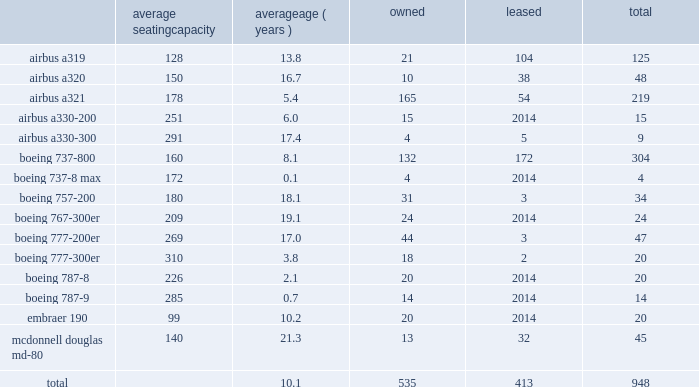Item 2 .
Properties flight equipment and fleet renewal as of december 31 , 2017 , american operated a mainline fleet of 948 aircraft .
In 2017 , we continued our extensive fleet renewal program , which has provided us with the youngest fleet of the major u.s .
Network carriers .
During 2017 , american took delivery of 57 new mainline aircraft and retired 39 mainline aircraft .
We are supported by our wholly-owned and third-party regional carriers that fly under capacity purchase agreements operating as american eagle .
As of december 31 , 2017 , american eagle operated 597 regional aircraft .
During 2017 , we reduced our regional fleet by a net of nine aircraft , including the addition of 63 regional aircraft and retirement of 72 regional aircraft .
Mainline as of december 31 , 2017 , american 2019s mainline fleet consisted of the following aircraft : average seating capacity average ( years ) owned leased total .

What percent of american's total planes carried fewer than 100 pasengers? 
Computations: (20 / 948)
Answer: 0.0211. 